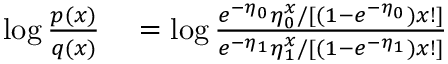Convert formula to latex. <formula><loc_0><loc_0><loc_500><loc_500>\begin{array} { r l } { \log \frac { p ( x ) } { q ( x ) } } & = \log \frac { e ^ { - \eta _ { 0 } } \eta _ { 0 } ^ { x } / [ ( 1 - e ^ { - \eta _ { 0 } } ) x ! ] } { e ^ { - \eta _ { 1 } } \eta _ { 1 } ^ { x } / [ ( 1 - e ^ { - \eta _ { 1 } } ) x ! ] } } \end{array}</formula> 